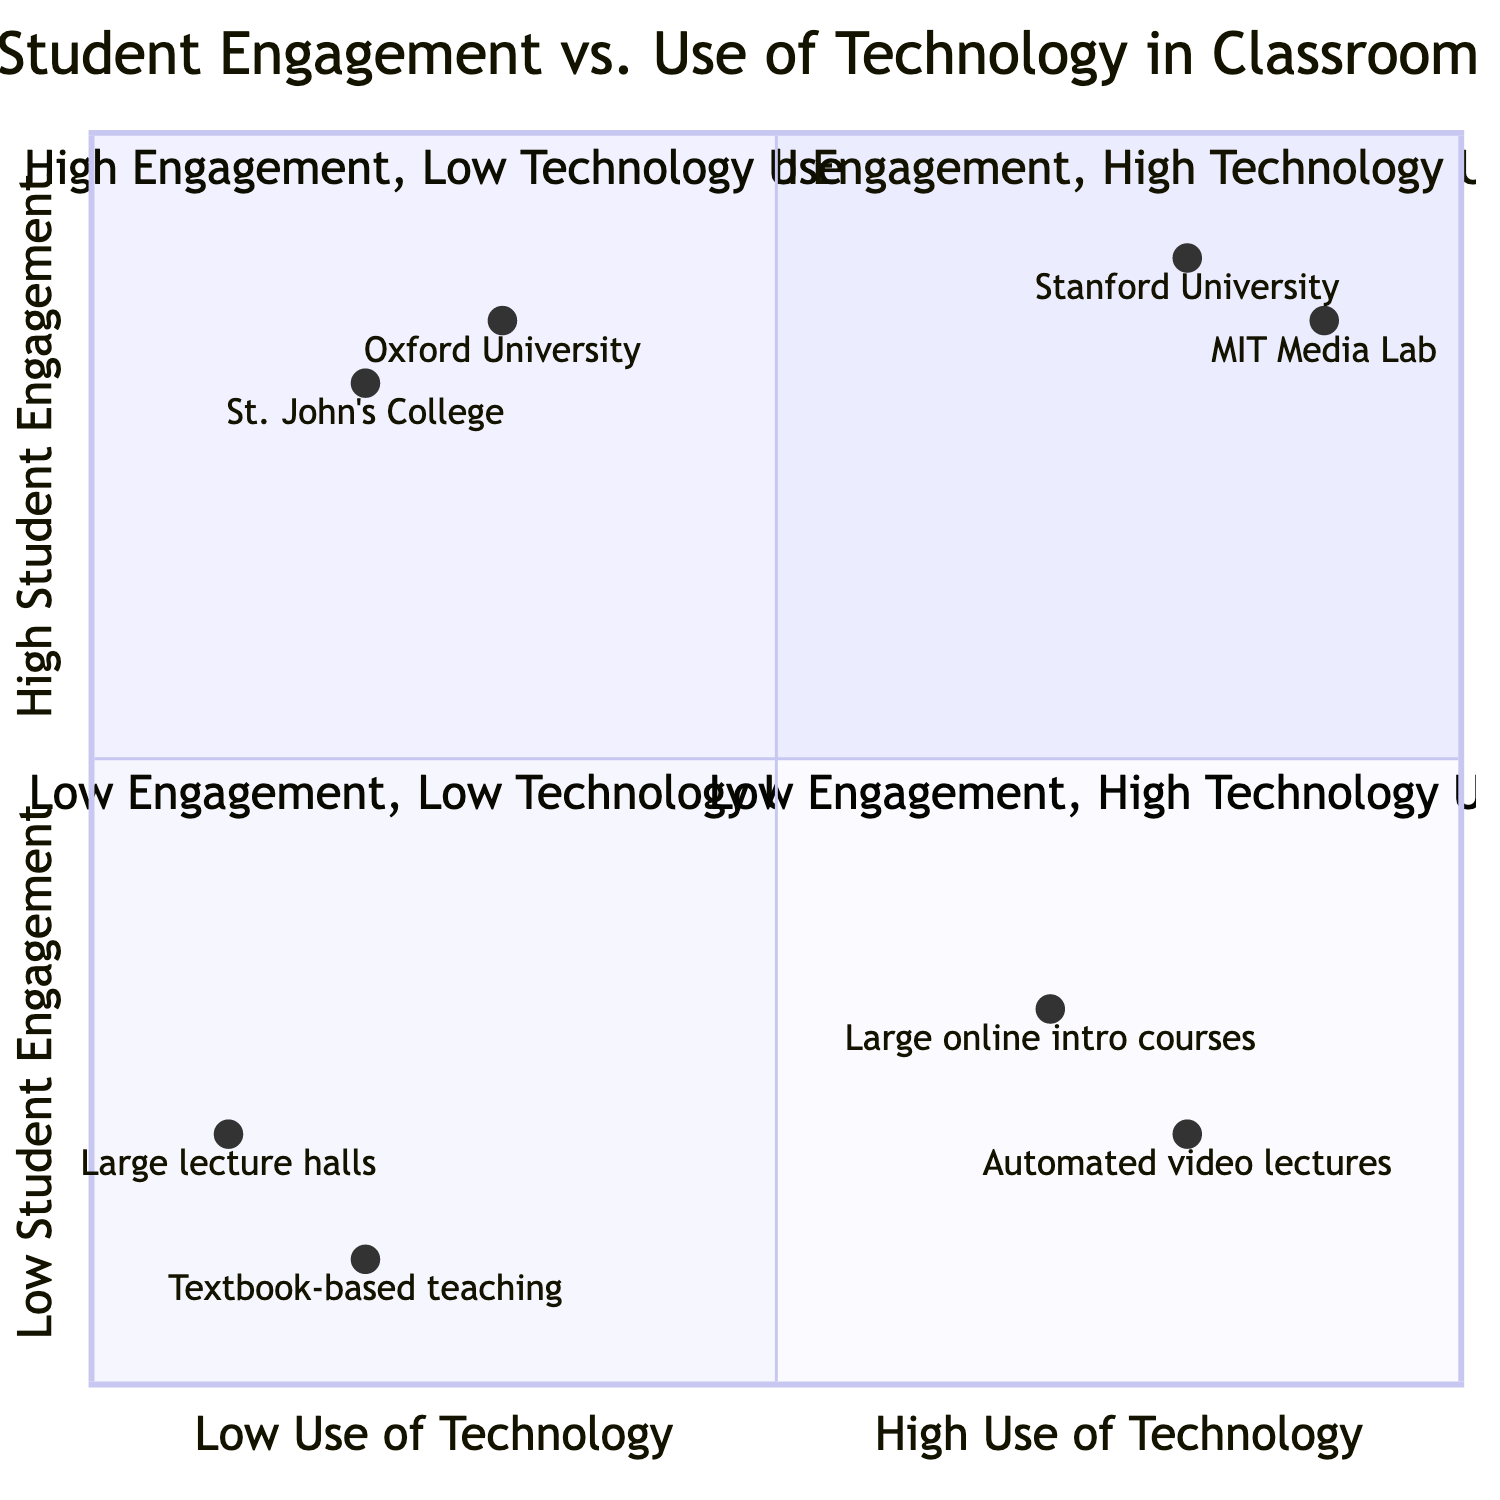What universities are in the 'High Engagement, High Technology Use' quadrant? The 'High Engagement, High Technology Use' quadrant includes Stanford University and MIT Media Lab as example institutions listed in the description.
Answer: Stanford University, MIT Media Lab Which quadrant has the lowest student engagement? The 'Low Engagement, Low Technology Use' quadrant is described as having minimal student interaction or practical application, indicating it has the lowest engagement.
Answer: Low Engagement, Low Technology Use How many quadrants are shown in the diagram? There are four quadrants identified in the chart: 'High Engagement, High Technology Use', 'High Engagement, Low Technology Use', 'Low Engagement, High Technology Use', and 'Low Engagement, Low Technology Use'.
Answer: Four What outcome correlates with 'High Engagement, High Technology Use'? The outcomes indicate that high learning outcomes are generally observed in the 'High Engagement, High Technology Use' quadrant.
Answer: High learning outcomes Which quadrant suggests a need for improvements in both technology use and engagement? The 'Low Engagement, Low Technology Use' quadrant indicates a need for improvements in both areas to enhance student achievement, as it is associated with lower learning outcomes.
Answer: Low Engagement, Low Technology Use What educational methods are highlighted in the 'High Engagement, Low Technology Use' quadrant? The educational methods mentioned include seminar-style discussions, Socratic method, and experiential learning, all indicative of engaging pedagogies without heavy reliance on technology.
Answer: Seminar-style discussions, Socratic method, experiential learning Which example represents 'Low Engagement, High Technology Use'? The example given for 'Low Engagement, High Technology Use' in the quadrant is poorly designed online courses, which indicate extensive technology use but lack effective engagement.
Answer: Large online introductory courses Which quadrant corresponds to lecture-based teaching with minimal interaction? The 'Low Engagement, Low Technology Use' quadrant includes traditional lecture-based teaching with minimal student interaction as one of its characteristics.
Answer: Low Engagement, Low Technology Use 